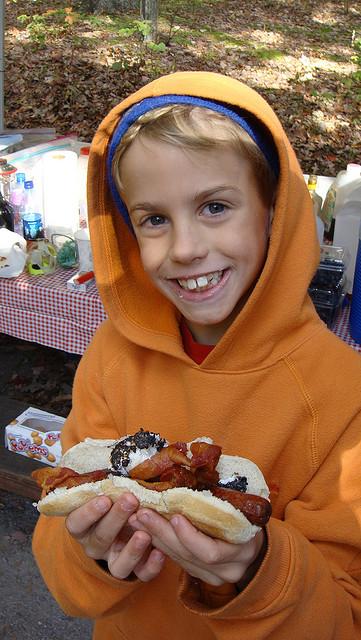Could this be a picnic?
Answer briefly. Yes. Does the boy have his teeth?
Keep it brief. Yes. What is the boy eating?
Give a very brief answer. Hot dog. 